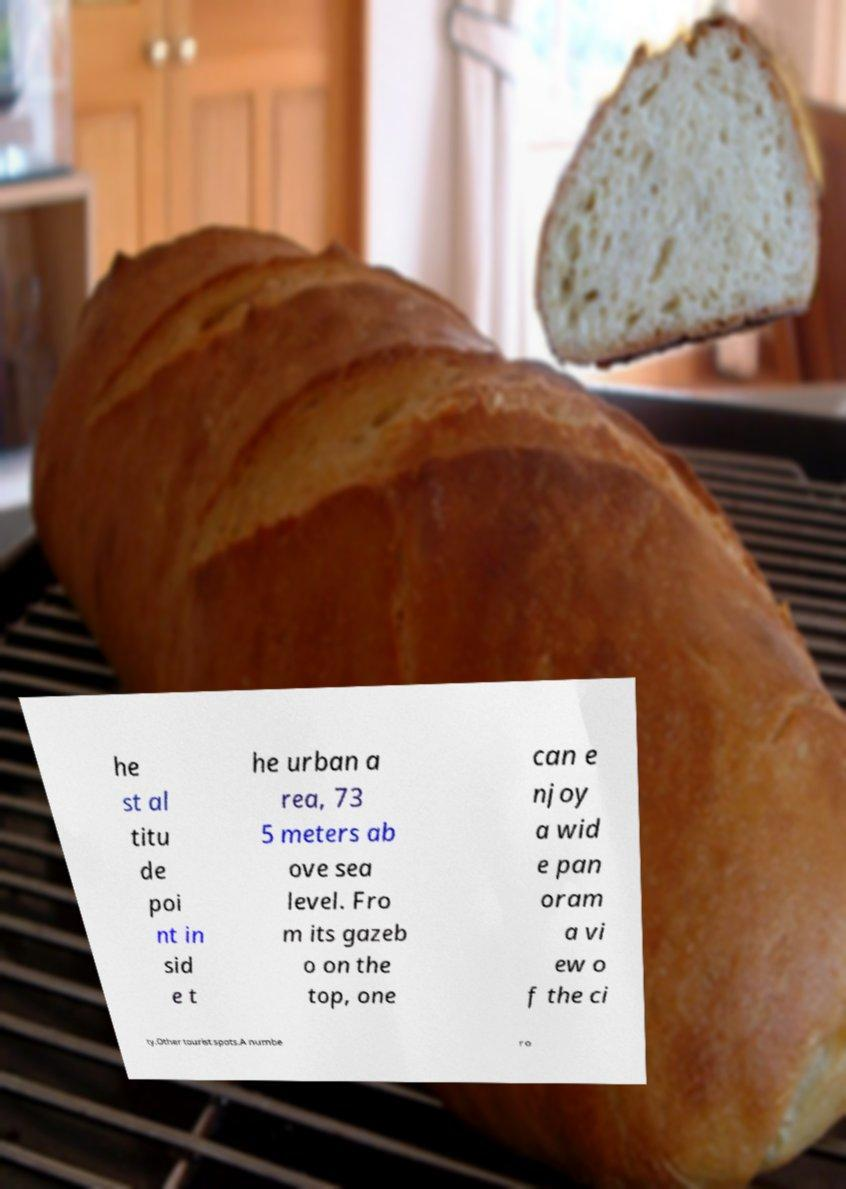What messages or text are displayed in this image? I need them in a readable, typed format. he st al titu de poi nt in sid e t he urban a rea, 73 5 meters ab ove sea level. Fro m its gazeb o on the top, one can e njoy a wid e pan oram a vi ew o f the ci ty.Other tourist spots.A numbe r o 